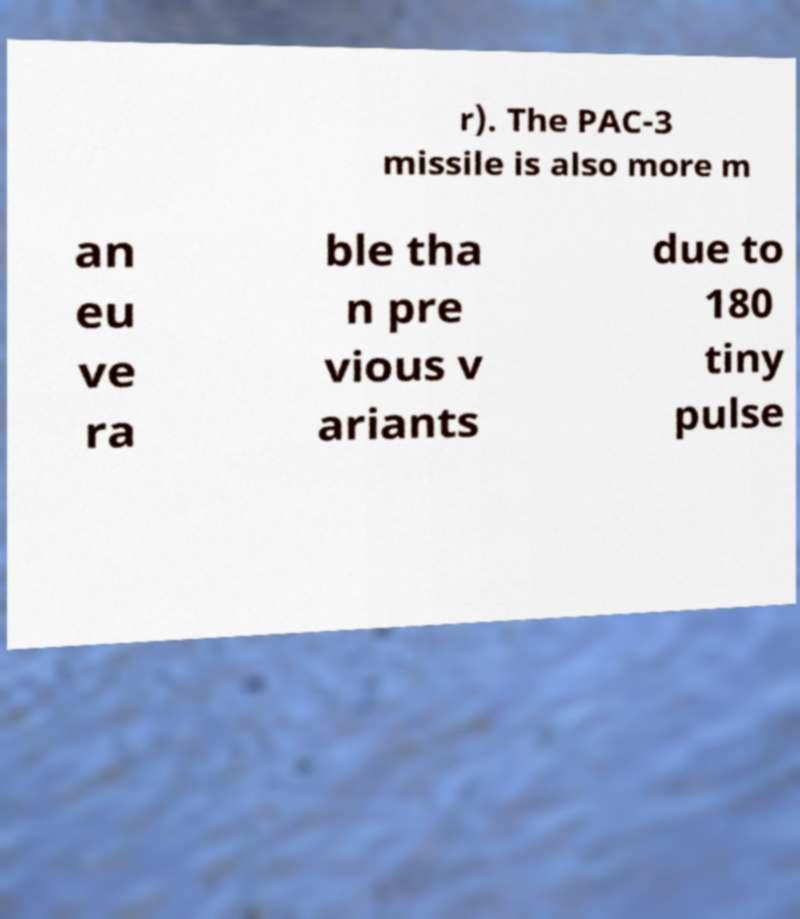For documentation purposes, I need the text within this image transcribed. Could you provide that? r). The PAC-3 missile is also more m an eu ve ra ble tha n pre vious v ariants due to 180 tiny pulse 